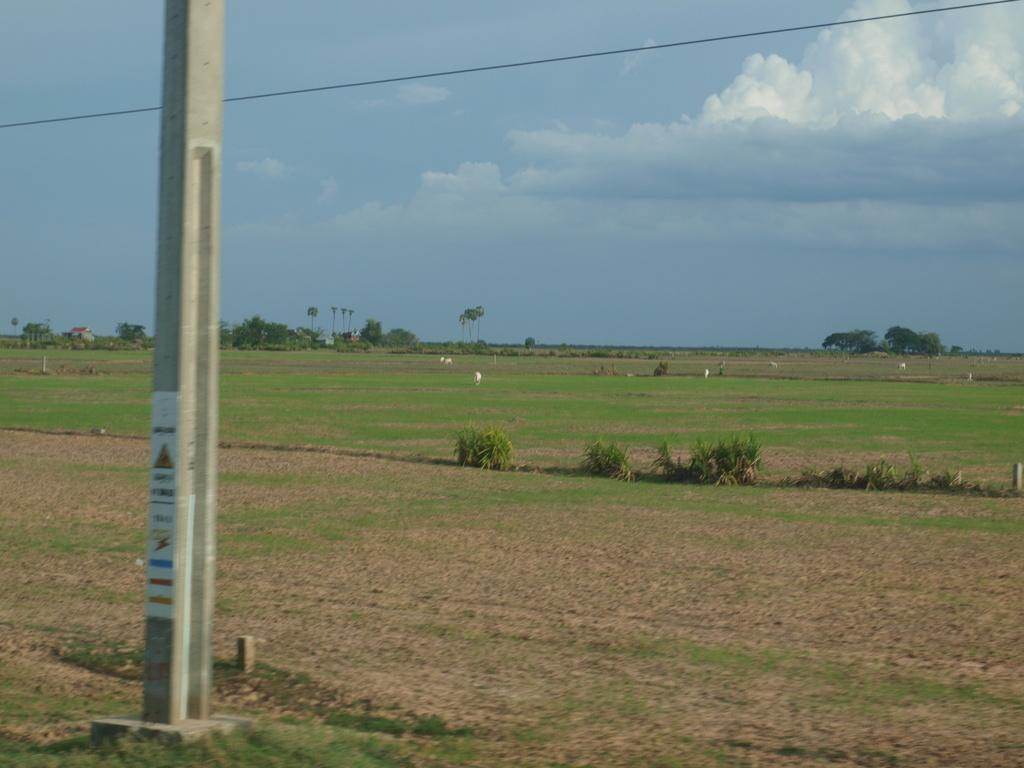What is located on the land in the image? There is a pole on the land. What type of vegetation is present on the land? The land has grass and plants. What other living beings can be seen on the land? There are animals on the land. What can be seen in the background of the image? There are trees in the background. What is visible at the top of the image? The sky is visible at the top of the image. What can be observed in the sky? There are clouds in the sky. What type of room can be seen in the image? There is no room present in the image; it features a pole, land, animals, trees, and sky. Is there a range of mountains visible in the image? There is no range of mountains present in the image; it features a pole, land, animals, trees, and sky. 